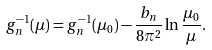<formula> <loc_0><loc_0><loc_500><loc_500>g _ { n } ^ { - 1 } ( \mu ) = g _ { n } ^ { - 1 } ( \mu _ { 0 } ) - \frac { b _ { n } } { 8 \pi ^ { 2 } } \ln \frac { \mu _ { 0 } } { \mu } .</formula> 